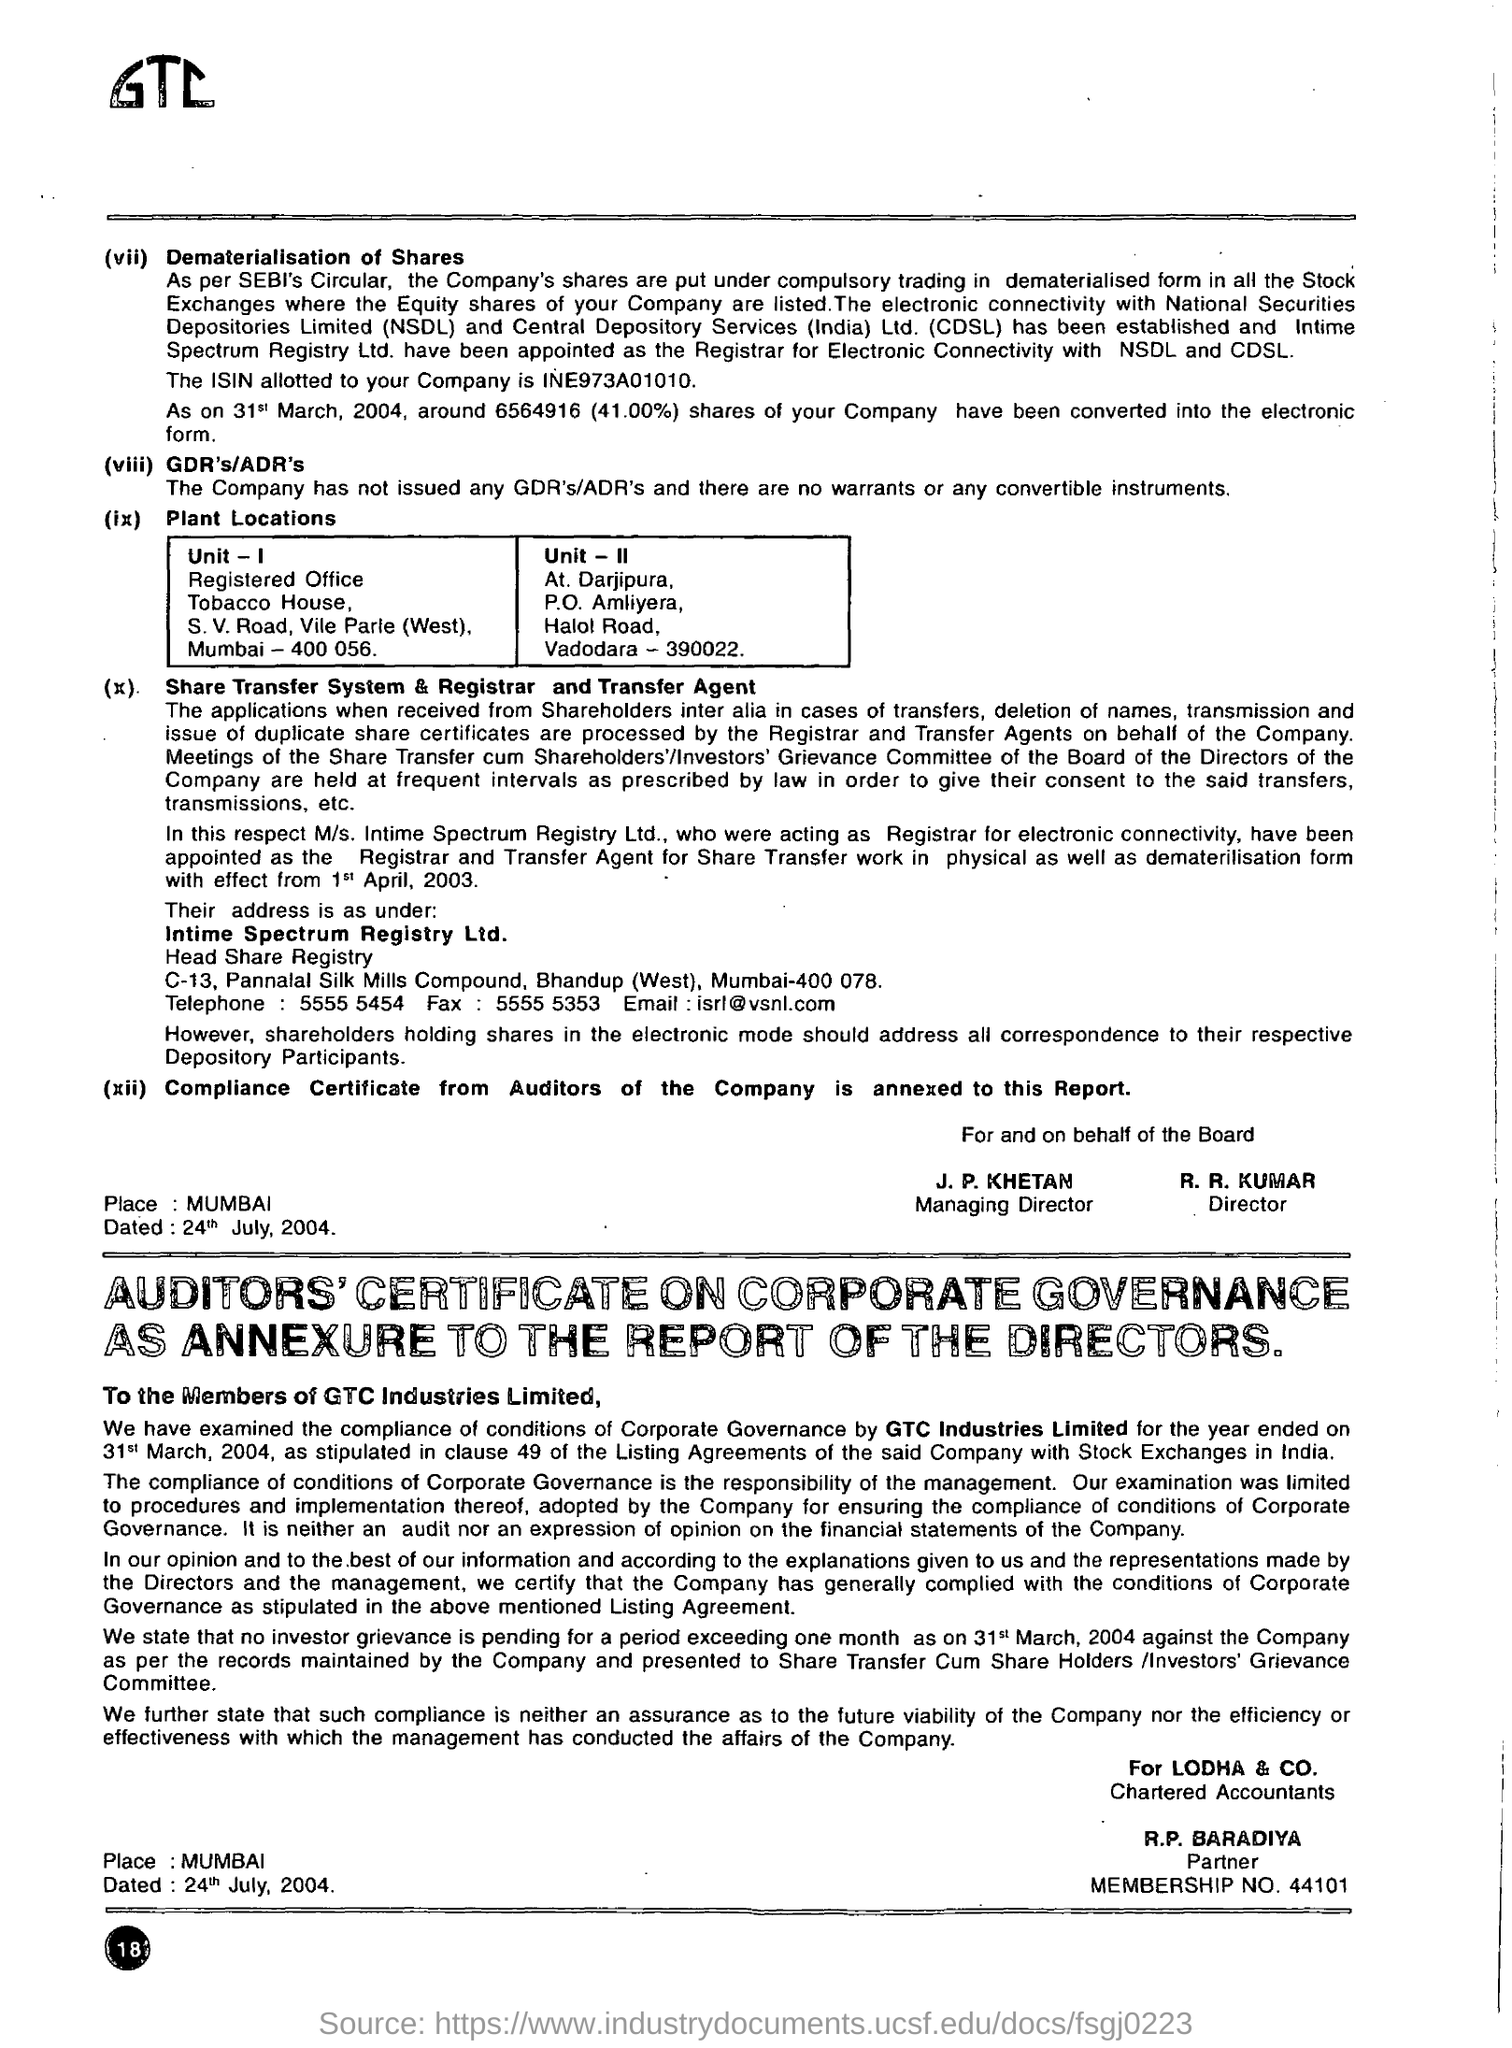Indicate a few pertinent items in this graphic. GTC Industries Limited is the name of the company. The membership number of R.P. BARADIYA is 44101... 